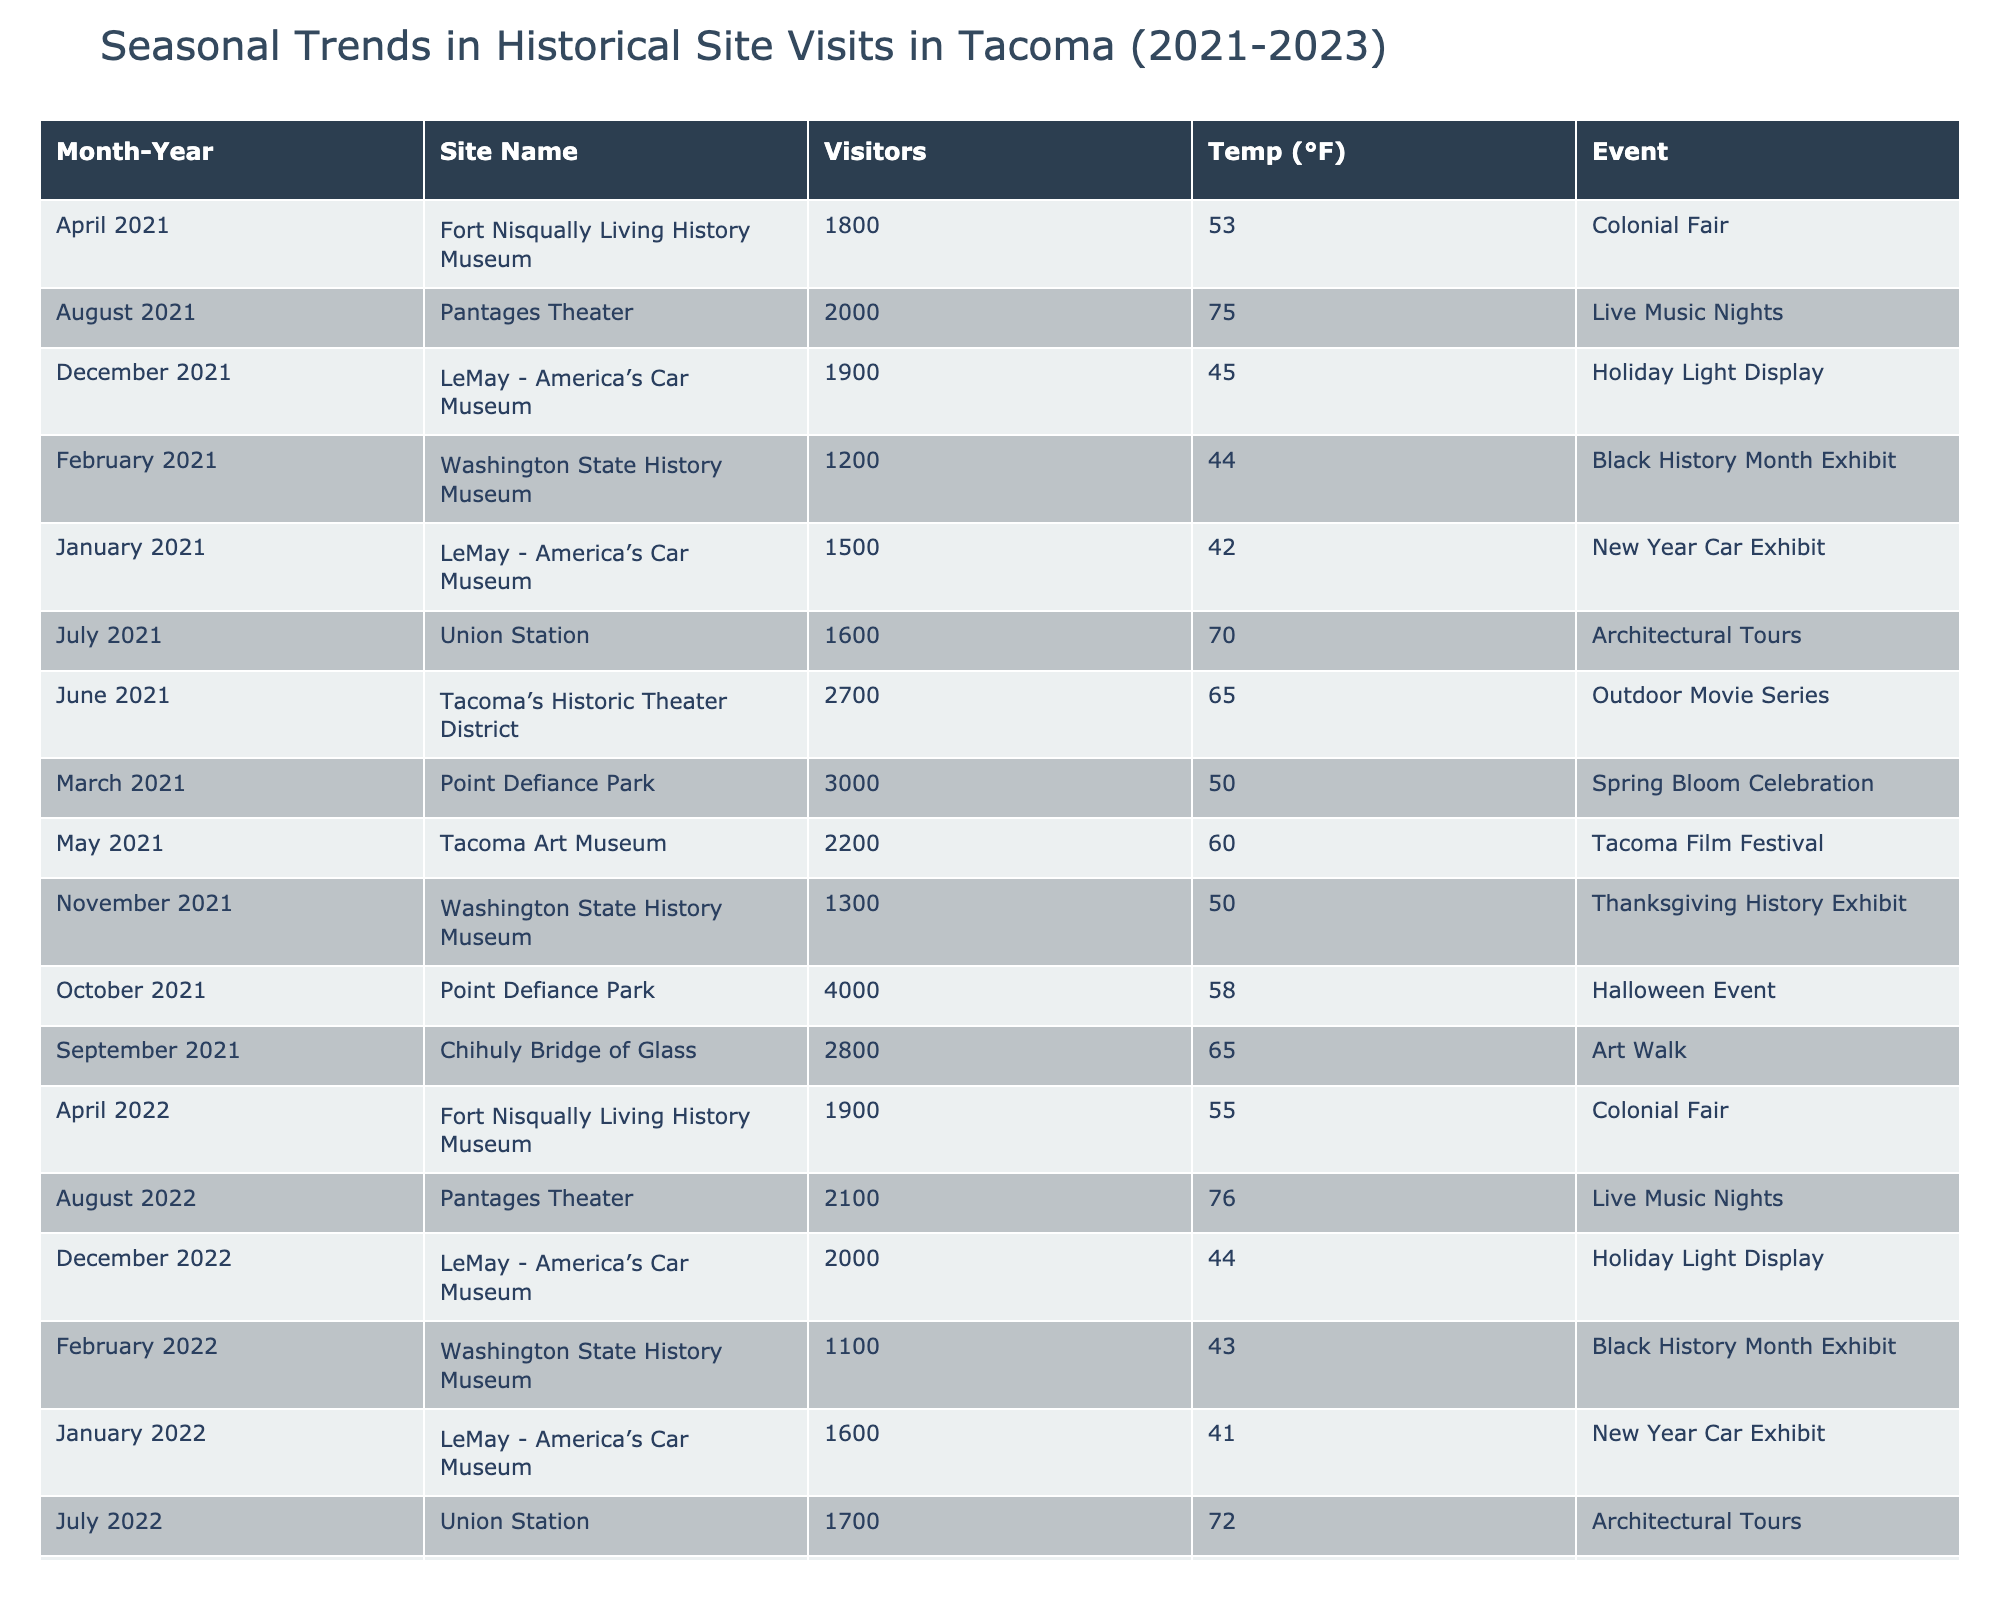What was the number of visitors to Point Defiance Park in October 2022? Looking for the entry in October 2022 for Point Defiance Park, the number of visitors listed is 4200.
Answer: 4200 Which site had the highest average temperature of visitors in June over the three years? The average temperatures for June across the years are: Tacoma's Historic Theater District in 2021 (65°F), 2022 (68°F) and 2023 (67°F). Comparing these, 68°F is the highest in 2022.
Answer: Tacoma's Historic Theater District What is the total number of visitors to Washington State History Museum across all three years? The visitors for Washington State History Museum are: 1200 in 2021, 1100 in 2022, and 1300 in 2023. Summing these gives 1200 + 1100 + 1300 = 3600 total visitors.
Answer: 3600 Did the number of visitors to LeMay - America’s Car Museum increase or decrease from January 2021 to January 2023? In January 2021, the visitors were 1500, and in January 2023, they were 1700. Since 1700 > 1500, this indicates an increase.
Answer: Yes What was the average number of visitors for the Tacoma Art Museum over three years? Tacoma Art Museum had visitors of 2200 in 2021, 2300 in 2022, and 2400 in 2023. Adding these gives 2200 + 2300 + 2400 = 6900. The average is 6900 divided by 3 which equals 2300.
Answer: 2300 Which month in 2023 saw the highest number of visitors at Point Defiance Park? In 2023, October had 4300 visitors and March had 3500 visitors. Since 4300 is greater than 3500, October is the month with the highest visitors.
Answer: October How many events were hosted at Fort Nisqually Living History Museum in total during the three years? Fort Nisqually Living History Museum hosted an event each year: Colonial Fair (2021), Colonial Fair (2022), and Colonial Fair (2023). Therefore, it hosted a total of three events.
Answer: 3 In which year did the Pantages Theater have the lowest visitor count? The Pantages Theater had 2000 visitors in August 2021, 2100 in August 2022, and 2200 in August 2023. Looking at these values, 2000 is the lowest. Thus, it was in 2021.
Answer: 2021 